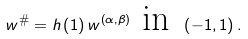Convert formula to latex. <formula><loc_0><loc_0><loc_500><loc_500>w ^ { \# } = h \left ( 1 \right ) w ^ { \left ( \alpha , \beta \right ) } \text { in } \left ( - 1 , 1 \right ) .</formula> 